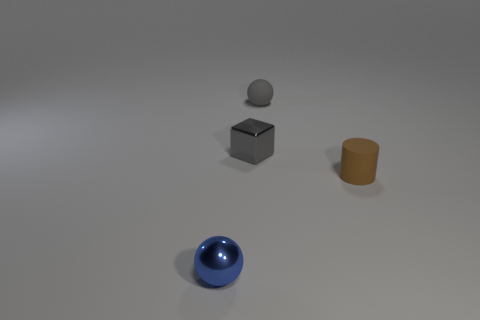What could be the context or purpose of this scene? This scene appears to be a minimalistic arrangement for a study in geometry and color. The stark lighting and neutral background suggest that it might be a setup for artistic display or a three-dimensional design model, emphasizing the basic shapes and contrasting colors of the objects. 